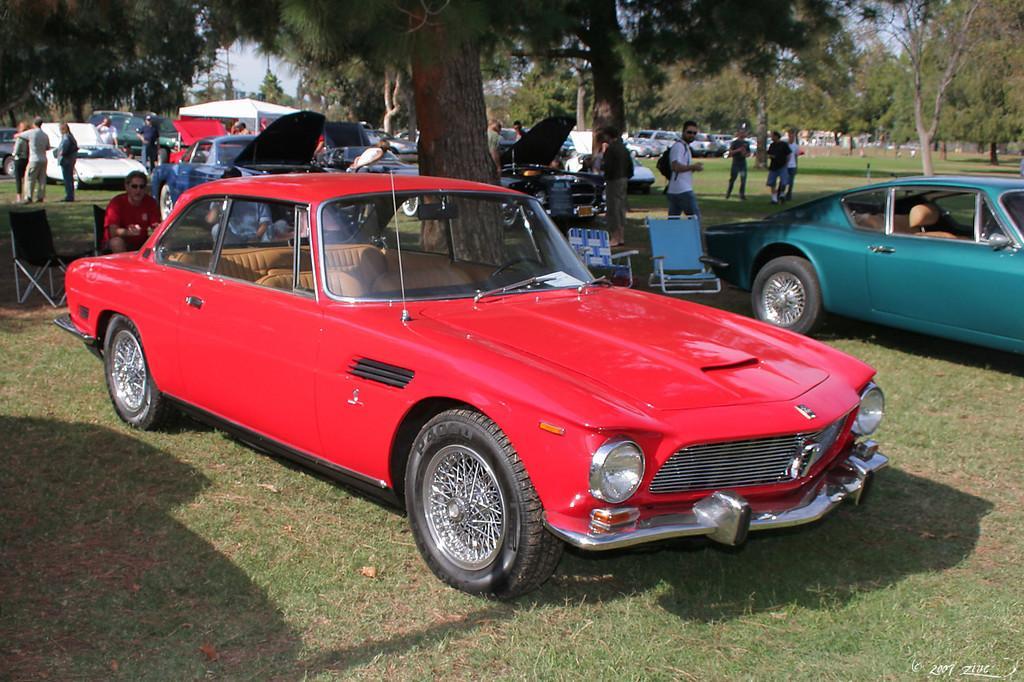Can you describe this image briefly? In this image I can see few vehicles in different colors. I can see few chairs, few people, trees, few objects and few are sitting on the chairs. 